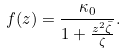<formula> <loc_0><loc_0><loc_500><loc_500>f ( z ) = \frac { \kappa _ { 0 } } { 1 + \frac { z ^ { 2 } \bar { \zeta } } { \zeta } } .</formula> 